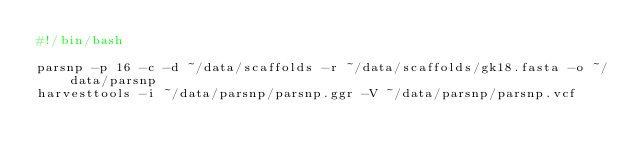Convert code to text. <code><loc_0><loc_0><loc_500><loc_500><_Bash_>#!/bin/bash

parsnp -p 16 -c -d ~/data/scaffolds -r ~/data/scaffolds/gk18.fasta -o ~/data/parsnp 
harvesttools -i ~/data/parsnp/parsnp.ggr -V ~/data/parsnp/parsnp.vcf
</code> 